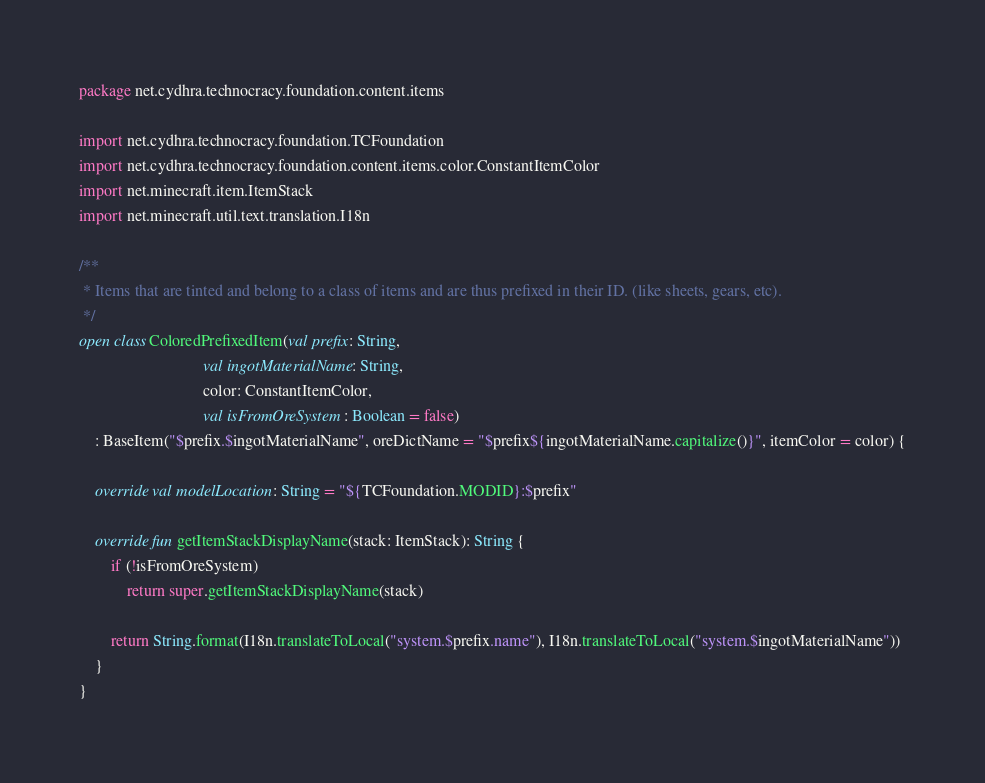<code> <loc_0><loc_0><loc_500><loc_500><_Kotlin_>package net.cydhra.technocracy.foundation.content.items

import net.cydhra.technocracy.foundation.TCFoundation
import net.cydhra.technocracy.foundation.content.items.color.ConstantItemColor
import net.minecraft.item.ItemStack
import net.minecraft.util.text.translation.I18n

/**
 * Items that are tinted and belong to a class of items and are thus prefixed in their ID. (like sheets, gears, etc).
 */
open class ColoredPrefixedItem(val prefix: String,
                               val ingotMaterialName: String,
                               color: ConstantItemColor,
                               val isFromOreSystem: Boolean = false)
    : BaseItem("$prefix.$ingotMaterialName", oreDictName = "$prefix${ingotMaterialName.capitalize()}", itemColor = color) {

    override val modelLocation: String = "${TCFoundation.MODID}:$prefix"

    override fun getItemStackDisplayName(stack: ItemStack): String {
        if (!isFromOreSystem)
            return super.getItemStackDisplayName(stack)

        return String.format(I18n.translateToLocal("system.$prefix.name"), I18n.translateToLocal("system.$ingotMaterialName"))
    }
}</code> 